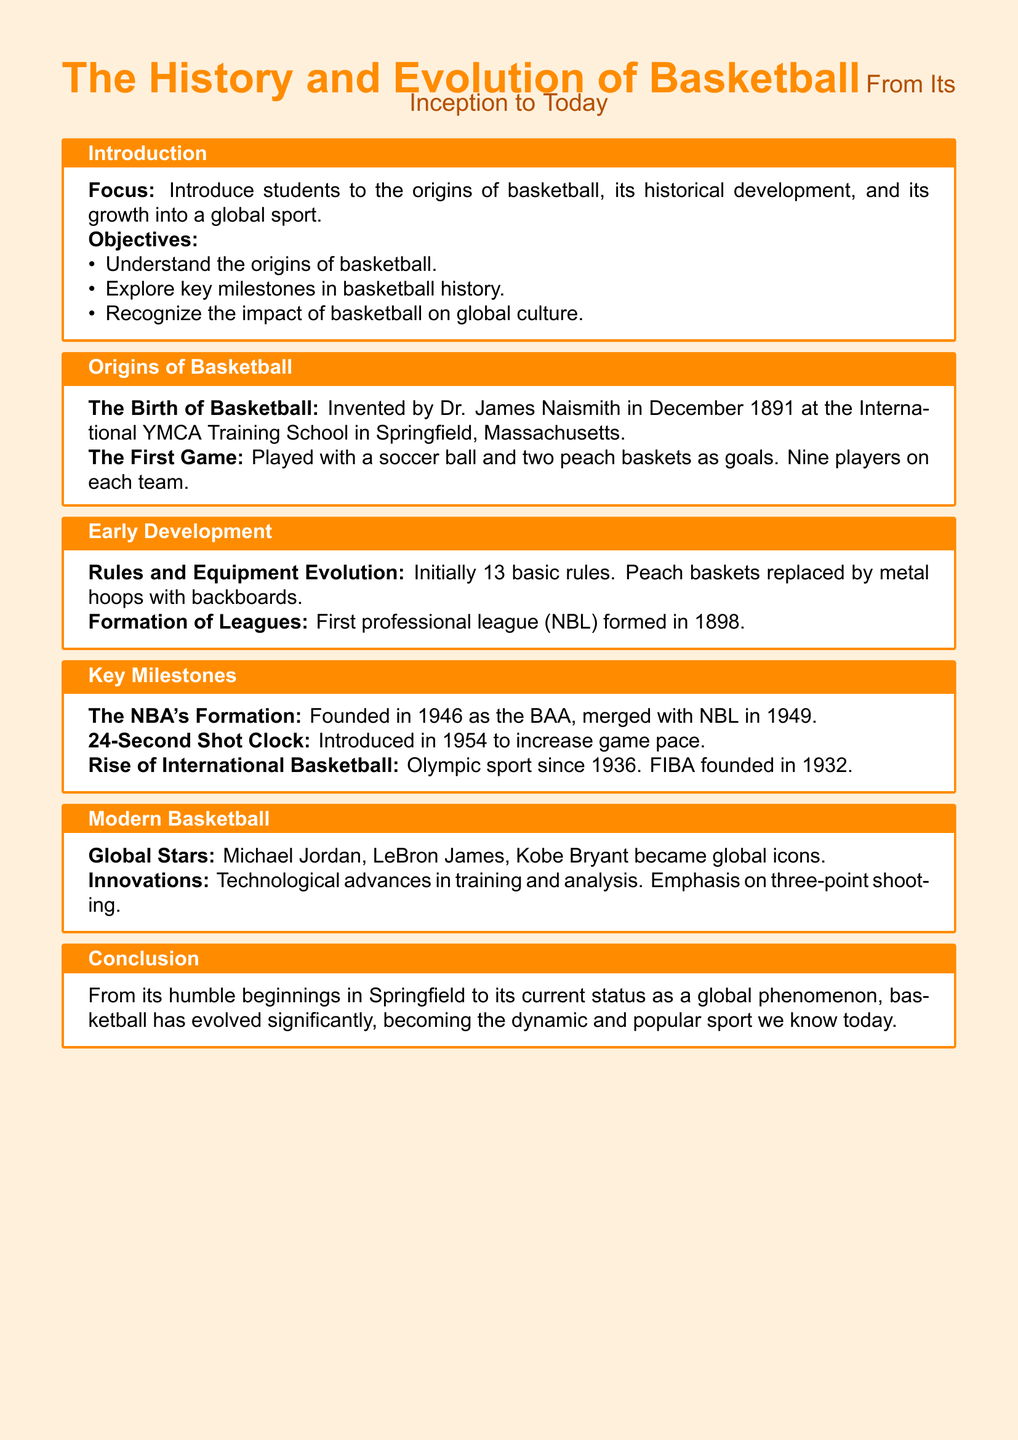what year was basketball invented? Basketball was invented in December 1891, as stated in the Origins of Basketball section.
Answer: 1891 who invented basketball? The document states that basketball was invented by Dr. James Naismith.
Answer: Dr. James Naismith what was used as the goals in the first basketball game? The first game used peach baskets as goals, according to the Origins of Basketball section.
Answer: peach baskets how many teams played in the first basketball game? The document indicates that there were nine players on each team in the first game.
Answer: two teams what important rule was introduced in 1954? The introduction of the 24-Second Shot Clock in 1954 is highlighted in the Key Milestones section.
Answer: 24-Second Shot Clock when did basketball become an Olympic sport? The document mentions that basketball became an Olympic sport in 1936.
Answer: 1936 which professional league was formed first? According to the Early Development section, the first professional league formed was the NBL in 1898.
Answer: NBL who are some of the global stars of modern basketball? The Modern Basketball section lists Michael Jordan, LeBron James, and Kobe Bryant as global stars.
Answer: Michael Jordan, LeBron James, Kobe Bryant what was the first name of the NBA? The document states that the NBA was founded as the BAA in 1946.
Answer: BAA 